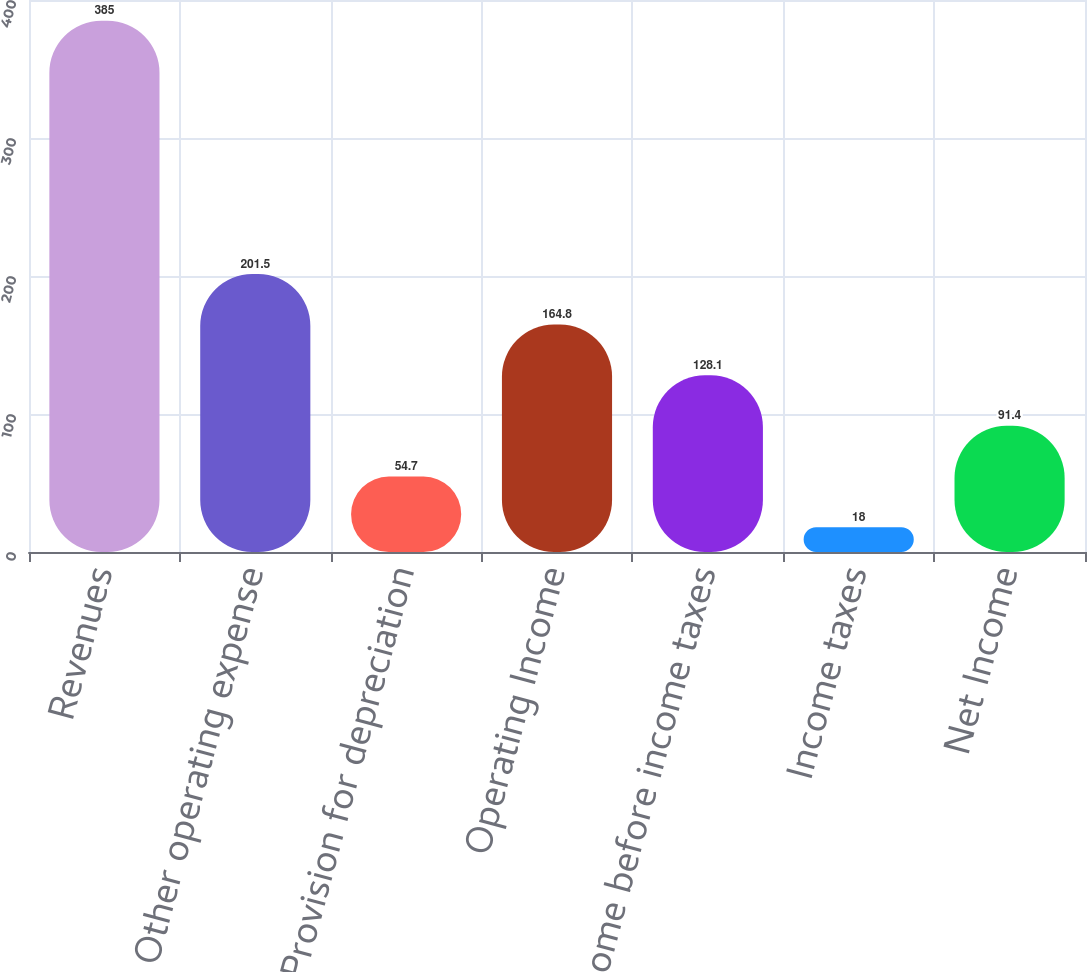Convert chart. <chart><loc_0><loc_0><loc_500><loc_500><bar_chart><fcel>Revenues<fcel>Other operating expense<fcel>Provision for depreciation<fcel>Operating Income<fcel>Income before income taxes<fcel>Income taxes<fcel>Net Income<nl><fcel>385<fcel>201.5<fcel>54.7<fcel>164.8<fcel>128.1<fcel>18<fcel>91.4<nl></chart> 